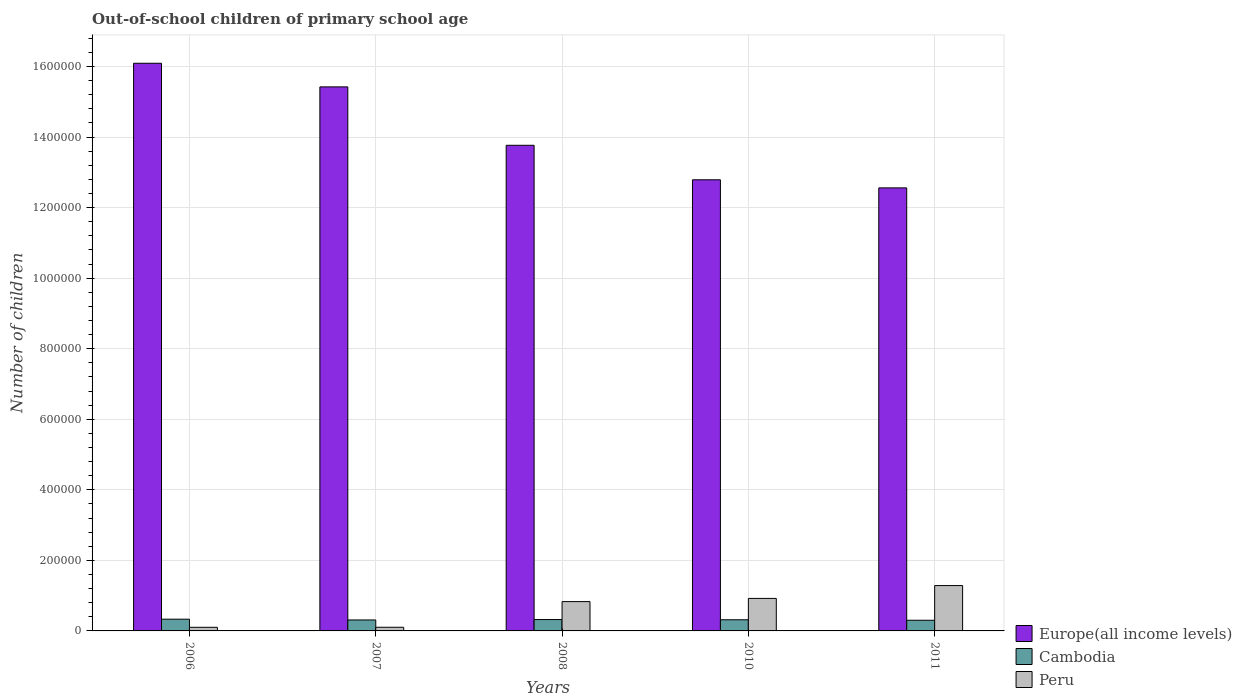Are the number of bars per tick equal to the number of legend labels?
Give a very brief answer. Yes. Are the number of bars on each tick of the X-axis equal?
Provide a short and direct response. Yes. How many bars are there on the 4th tick from the right?
Your answer should be very brief. 3. What is the label of the 3rd group of bars from the left?
Your answer should be very brief. 2008. In how many cases, is the number of bars for a given year not equal to the number of legend labels?
Provide a succinct answer. 0. What is the number of out-of-school children in Europe(all income levels) in 2010?
Make the answer very short. 1.28e+06. Across all years, what is the maximum number of out-of-school children in Cambodia?
Your response must be concise. 3.33e+04. Across all years, what is the minimum number of out-of-school children in Europe(all income levels)?
Provide a short and direct response. 1.26e+06. In which year was the number of out-of-school children in Europe(all income levels) maximum?
Make the answer very short. 2006. What is the total number of out-of-school children in Europe(all income levels) in the graph?
Ensure brevity in your answer.  7.06e+06. What is the difference between the number of out-of-school children in Cambodia in 2006 and that in 2007?
Give a very brief answer. 2244. What is the difference between the number of out-of-school children in Cambodia in 2007 and the number of out-of-school children in Europe(all income levels) in 2010?
Keep it short and to the point. -1.25e+06. What is the average number of out-of-school children in Peru per year?
Keep it short and to the point. 6.49e+04. In the year 2007, what is the difference between the number of out-of-school children in Cambodia and number of out-of-school children in Europe(all income levels)?
Offer a terse response. -1.51e+06. In how many years, is the number of out-of-school children in Europe(all income levels) greater than 1040000?
Ensure brevity in your answer.  5. What is the ratio of the number of out-of-school children in Cambodia in 2006 to that in 2011?
Your answer should be very brief. 1.1. Is the difference between the number of out-of-school children in Cambodia in 2006 and 2010 greater than the difference between the number of out-of-school children in Europe(all income levels) in 2006 and 2010?
Your response must be concise. No. What is the difference between the highest and the second highest number of out-of-school children in Cambodia?
Provide a short and direct response. 1097. What is the difference between the highest and the lowest number of out-of-school children in Europe(all income levels)?
Offer a terse response. 3.53e+05. What does the 2nd bar from the left in 2006 represents?
Your response must be concise. Cambodia. How many bars are there?
Your answer should be compact. 15. Are all the bars in the graph horizontal?
Give a very brief answer. No. How many years are there in the graph?
Ensure brevity in your answer.  5. What is the difference between two consecutive major ticks on the Y-axis?
Offer a very short reply. 2.00e+05. Does the graph contain any zero values?
Your answer should be very brief. No. Does the graph contain grids?
Offer a terse response. Yes. How many legend labels are there?
Your response must be concise. 3. What is the title of the graph?
Your response must be concise. Out-of-school children of primary school age. Does "Puerto Rico" appear as one of the legend labels in the graph?
Your answer should be compact. No. What is the label or title of the Y-axis?
Offer a terse response. Number of children. What is the Number of children of Europe(all income levels) in 2006?
Ensure brevity in your answer.  1.61e+06. What is the Number of children of Cambodia in 2006?
Your response must be concise. 3.33e+04. What is the Number of children in Peru in 2006?
Offer a terse response. 1.03e+04. What is the Number of children of Europe(all income levels) in 2007?
Your answer should be compact. 1.54e+06. What is the Number of children in Cambodia in 2007?
Keep it short and to the point. 3.11e+04. What is the Number of children of Peru in 2007?
Ensure brevity in your answer.  1.04e+04. What is the Number of children of Europe(all income levels) in 2008?
Offer a terse response. 1.38e+06. What is the Number of children of Cambodia in 2008?
Make the answer very short. 3.22e+04. What is the Number of children of Peru in 2008?
Give a very brief answer. 8.31e+04. What is the Number of children in Europe(all income levels) in 2010?
Your answer should be compact. 1.28e+06. What is the Number of children of Cambodia in 2010?
Make the answer very short. 3.16e+04. What is the Number of children of Peru in 2010?
Provide a short and direct response. 9.21e+04. What is the Number of children of Europe(all income levels) in 2011?
Provide a short and direct response. 1.26e+06. What is the Number of children of Cambodia in 2011?
Make the answer very short. 3.02e+04. What is the Number of children in Peru in 2011?
Your answer should be very brief. 1.29e+05. Across all years, what is the maximum Number of children of Europe(all income levels)?
Offer a terse response. 1.61e+06. Across all years, what is the maximum Number of children in Cambodia?
Provide a short and direct response. 3.33e+04. Across all years, what is the maximum Number of children in Peru?
Offer a very short reply. 1.29e+05. Across all years, what is the minimum Number of children of Europe(all income levels)?
Keep it short and to the point. 1.26e+06. Across all years, what is the minimum Number of children of Cambodia?
Keep it short and to the point. 3.02e+04. Across all years, what is the minimum Number of children in Peru?
Provide a succinct answer. 1.03e+04. What is the total Number of children of Europe(all income levels) in the graph?
Offer a very short reply. 7.06e+06. What is the total Number of children of Cambodia in the graph?
Give a very brief answer. 1.58e+05. What is the total Number of children of Peru in the graph?
Your response must be concise. 3.24e+05. What is the difference between the Number of children of Europe(all income levels) in 2006 and that in 2007?
Your answer should be very brief. 6.69e+04. What is the difference between the Number of children of Cambodia in 2006 and that in 2007?
Your response must be concise. 2244. What is the difference between the Number of children of Peru in 2006 and that in 2007?
Your answer should be compact. -136. What is the difference between the Number of children in Europe(all income levels) in 2006 and that in 2008?
Your response must be concise. 2.33e+05. What is the difference between the Number of children in Cambodia in 2006 and that in 2008?
Provide a short and direct response. 1097. What is the difference between the Number of children of Peru in 2006 and that in 2008?
Provide a succinct answer. -7.29e+04. What is the difference between the Number of children in Europe(all income levels) in 2006 and that in 2010?
Keep it short and to the point. 3.30e+05. What is the difference between the Number of children of Cambodia in 2006 and that in 2010?
Offer a terse response. 1695. What is the difference between the Number of children in Peru in 2006 and that in 2010?
Your response must be concise. -8.19e+04. What is the difference between the Number of children in Europe(all income levels) in 2006 and that in 2011?
Your response must be concise. 3.53e+05. What is the difference between the Number of children of Cambodia in 2006 and that in 2011?
Your answer should be compact. 3092. What is the difference between the Number of children of Peru in 2006 and that in 2011?
Keep it short and to the point. -1.18e+05. What is the difference between the Number of children in Europe(all income levels) in 2007 and that in 2008?
Keep it short and to the point. 1.66e+05. What is the difference between the Number of children of Cambodia in 2007 and that in 2008?
Your answer should be compact. -1147. What is the difference between the Number of children of Peru in 2007 and that in 2008?
Your answer should be compact. -7.27e+04. What is the difference between the Number of children in Europe(all income levels) in 2007 and that in 2010?
Your answer should be compact. 2.63e+05. What is the difference between the Number of children in Cambodia in 2007 and that in 2010?
Your answer should be very brief. -549. What is the difference between the Number of children in Peru in 2007 and that in 2010?
Keep it short and to the point. -8.18e+04. What is the difference between the Number of children of Europe(all income levels) in 2007 and that in 2011?
Ensure brevity in your answer.  2.86e+05. What is the difference between the Number of children of Cambodia in 2007 and that in 2011?
Provide a short and direct response. 848. What is the difference between the Number of children in Peru in 2007 and that in 2011?
Give a very brief answer. -1.18e+05. What is the difference between the Number of children in Europe(all income levels) in 2008 and that in 2010?
Make the answer very short. 9.78e+04. What is the difference between the Number of children of Cambodia in 2008 and that in 2010?
Provide a succinct answer. 598. What is the difference between the Number of children of Peru in 2008 and that in 2010?
Provide a succinct answer. -9027. What is the difference between the Number of children of Europe(all income levels) in 2008 and that in 2011?
Offer a terse response. 1.21e+05. What is the difference between the Number of children of Cambodia in 2008 and that in 2011?
Give a very brief answer. 1995. What is the difference between the Number of children of Peru in 2008 and that in 2011?
Offer a terse response. -4.54e+04. What is the difference between the Number of children of Europe(all income levels) in 2010 and that in 2011?
Give a very brief answer. 2.30e+04. What is the difference between the Number of children of Cambodia in 2010 and that in 2011?
Provide a succinct answer. 1397. What is the difference between the Number of children of Peru in 2010 and that in 2011?
Provide a succinct answer. -3.64e+04. What is the difference between the Number of children of Europe(all income levels) in 2006 and the Number of children of Cambodia in 2007?
Give a very brief answer. 1.58e+06. What is the difference between the Number of children in Europe(all income levels) in 2006 and the Number of children in Peru in 2007?
Your response must be concise. 1.60e+06. What is the difference between the Number of children of Cambodia in 2006 and the Number of children of Peru in 2007?
Make the answer very short. 2.29e+04. What is the difference between the Number of children in Europe(all income levels) in 2006 and the Number of children in Cambodia in 2008?
Provide a short and direct response. 1.58e+06. What is the difference between the Number of children of Europe(all income levels) in 2006 and the Number of children of Peru in 2008?
Make the answer very short. 1.53e+06. What is the difference between the Number of children of Cambodia in 2006 and the Number of children of Peru in 2008?
Ensure brevity in your answer.  -4.98e+04. What is the difference between the Number of children of Europe(all income levels) in 2006 and the Number of children of Cambodia in 2010?
Ensure brevity in your answer.  1.58e+06. What is the difference between the Number of children in Europe(all income levels) in 2006 and the Number of children in Peru in 2010?
Your answer should be very brief. 1.52e+06. What is the difference between the Number of children in Cambodia in 2006 and the Number of children in Peru in 2010?
Make the answer very short. -5.88e+04. What is the difference between the Number of children of Europe(all income levels) in 2006 and the Number of children of Cambodia in 2011?
Make the answer very short. 1.58e+06. What is the difference between the Number of children of Europe(all income levels) in 2006 and the Number of children of Peru in 2011?
Offer a terse response. 1.48e+06. What is the difference between the Number of children of Cambodia in 2006 and the Number of children of Peru in 2011?
Your response must be concise. -9.52e+04. What is the difference between the Number of children in Europe(all income levels) in 2007 and the Number of children in Cambodia in 2008?
Offer a terse response. 1.51e+06. What is the difference between the Number of children in Europe(all income levels) in 2007 and the Number of children in Peru in 2008?
Your answer should be very brief. 1.46e+06. What is the difference between the Number of children of Cambodia in 2007 and the Number of children of Peru in 2008?
Your answer should be very brief. -5.21e+04. What is the difference between the Number of children in Europe(all income levels) in 2007 and the Number of children in Cambodia in 2010?
Keep it short and to the point. 1.51e+06. What is the difference between the Number of children in Europe(all income levels) in 2007 and the Number of children in Peru in 2010?
Provide a short and direct response. 1.45e+06. What is the difference between the Number of children of Cambodia in 2007 and the Number of children of Peru in 2010?
Provide a succinct answer. -6.11e+04. What is the difference between the Number of children in Europe(all income levels) in 2007 and the Number of children in Cambodia in 2011?
Offer a terse response. 1.51e+06. What is the difference between the Number of children in Europe(all income levels) in 2007 and the Number of children in Peru in 2011?
Keep it short and to the point. 1.41e+06. What is the difference between the Number of children in Cambodia in 2007 and the Number of children in Peru in 2011?
Offer a terse response. -9.75e+04. What is the difference between the Number of children of Europe(all income levels) in 2008 and the Number of children of Cambodia in 2010?
Provide a succinct answer. 1.34e+06. What is the difference between the Number of children of Europe(all income levels) in 2008 and the Number of children of Peru in 2010?
Your answer should be compact. 1.28e+06. What is the difference between the Number of children in Cambodia in 2008 and the Number of children in Peru in 2010?
Provide a succinct answer. -5.99e+04. What is the difference between the Number of children of Europe(all income levels) in 2008 and the Number of children of Cambodia in 2011?
Your answer should be compact. 1.35e+06. What is the difference between the Number of children in Europe(all income levels) in 2008 and the Number of children in Peru in 2011?
Give a very brief answer. 1.25e+06. What is the difference between the Number of children of Cambodia in 2008 and the Number of children of Peru in 2011?
Ensure brevity in your answer.  -9.63e+04. What is the difference between the Number of children of Europe(all income levels) in 2010 and the Number of children of Cambodia in 2011?
Keep it short and to the point. 1.25e+06. What is the difference between the Number of children in Europe(all income levels) in 2010 and the Number of children in Peru in 2011?
Ensure brevity in your answer.  1.15e+06. What is the difference between the Number of children of Cambodia in 2010 and the Number of children of Peru in 2011?
Your response must be concise. -9.69e+04. What is the average Number of children of Europe(all income levels) per year?
Offer a very short reply. 1.41e+06. What is the average Number of children of Cambodia per year?
Ensure brevity in your answer.  3.17e+04. What is the average Number of children of Peru per year?
Give a very brief answer. 6.49e+04. In the year 2006, what is the difference between the Number of children in Europe(all income levels) and Number of children in Cambodia?
Give a very brief answer. 1.58e+06. In the year 2006, what is the difference between the Number of children of Europe(all income levels) and Number of children of Peru?
Keep it short and to the point. 1.60e+06. In the year 2006, what is the difference between the Number of children of Cambodia and Number of children of Peru?
Make the answer very short. 2.30e+04. In the year 2007, what is the difference between the Number of children in Europe(all income levels) and Number of children in Cambodia?
Offer a very short reply. 1.51e+06. In the year 2007, what is the difference between the Number of children in Europe(all income levels) and Number of children in Peru?
Ensure brevity in your answer.  1.53e+06. In the year 2007, what is the difference between the Number of children in Cambodia and Number of children in Peru?
Offer a very short reply. 2.07e+04. In the year 2008, what is the difference between the Number of children of Europe(all income levels) and Number of children of Cambodia?
Make the answer very short. 1.34e+06. In the year 2008, what is the difference between the Number of children in Europe(all income levels) and Number of children in Peru?
Provide a short and direct response. 1.29e+06. In the year 2008, what is the difference between the Number of children of Cambodia and Number of children of Peru?
Your answer should be compact. -5.09e+04. In the year 2010, what is the difference between the Number of children in Europe(all income levels) and Number of children in Cambodia?
Offer a terse response. 1.25e+06. In the year 2010, what is the difference between the Number of children of Europe(all income levels) and Number of children of Peru?
Provide a short and direct response. 1.19e+06. In the year 2010, what is the difference between the Number of children of Cambodia and Number of children of Peru?
Offer a terse response. -6.05e+04. In the year 2011, what is the difference between the Number of children in Europe(all income levels) and Number of children in Cambodia?
Provide a short and direct response. 1.23e+06. In the year 2011, what is the difference between the Number of children in Europe(all income levels) and Number of children in Peru?
Ensure brevity in your answer.  1.13e+06. In the year 2011, what is the difference between the Number of children of Cambodia and Number of children of Peru?
Provide a succinct answer. -9.83e+04. What is the ratio of the Number of children in Europe(all income levels) in 2006 to that in 2007?
Keep it short and to the point. 1.04. What is the ratio of the Number of children in Cambodia in 2006 to that in 2007?
Your answer should be very brief. 1.07. What is the ratio of the Number of children in Peru in 2006 to that in 2007?
Ensure brevity in your answer.  0.99. What is the ratio of the Number of children of Europe(all income levels) in 2006 to that in 2008?
Offer a very short reply. 1.17. What is the ratio of the Number of children in Cambodia in 2006 to that in 2008?
Offer a terse response. 1.03. What is the ratio of the Number of children in Peru in 2006 to that in 2008?
Give a very brief answer. 0.12. What is the ratio of the Number of children in Europe(all income levels) in 2006 to that in 2010?
Make the answer very short. 1.26. What is the ratio of the Number of children in Cambodia in 2006 to that in 2010?
Keep it short and to the point. 1.05. What is the ratio of the Number of children in Peru in 2006 to that in 2010?
Make the answer very short. 0.11. What is the ratio of the Number of children of Europe(all income levels) in 2006 to that in 2011?
Offer a terse response. 1.28. What is the ratio of the Number of children of Cambodia in 2006 to that in 2011?
Provide a short and direct response. 1.1. What is the ratio of the Number of children of Peru in 2006 to that in 2011?
Ensure brevity in your answer.  0.08. What is the ratio of the Number of children in Europe(all income levels) in 2007 to that in 2008?
Keep it short and to the point. 1.12. What is the ratio of the Number of children in Cambodia in 2007 to that in 2008?
Provide a short and direct response. 0.96. What is the ratio of the Number of children in Europe(all income levels) in 2007 to that in 2010?
Make the answer very short. 1.21. What is the ratio of the Number of children of Cambodia in 2007 to that in 2010?
Your response must be concise. 0.98. What is the ratio of the Number of children of Peru in 2007 to that in 2010?
Ensure brevity in your answer.  0.11. What is the ratio of the Number of children of Europe(all income levels) in 2007 to that in 2011?
Make the answer very short. 1.23. What is the ratio of the Number of children in Cambodia in 2007 to that in 2011?
Your answer should be compact. 1.03. What is the ratio of the Number of children of Peru in 2007 to that in 2011?
Your response must be concise. 0.08. What is the ratio of the Number of children in Europe(all income levels) in 2008 to that in 2010?
Ensure brevity in your answer.  1.08. What is the ratio of the Number of children of Cambodia in 2008 to that in 2010?
Ensure brevity in your answer.  1.02. What is the ratio of the Number of children in Peru in 2008 to that in 2010?
Your answer should be very brief. 0.9. What is the ratio of the Number of children of Europe(all income levels) in 2008 to that in 2011?
Keep it short and to the point. 1.1. What is the ratio of the Number of children in Cambodia in 2008 to that in 2011?
Your response must be concise. 1.07. What is the ratio of the Number of children of Peru in 2008 to that in 2011?
Give a very brief answer. 0.65. What is the ratio of the Number of children in Europe(all income levels) in 2010 to that in 2011?
Offer a very short reply. 1.02. What is the ratio of the Number of children of Cambodia in 2010 to that in 2011?
Keep it short and to the point. 1.05. What is the ratio of the Number of children of Peru in 2010 to that in 2011?
Keep it short and to the point. 0.72. What is the difference between the highest and the second highest Number of children in Europe(all income levels)?
Offer a very short reply. 6.69e+04. What is the difference between the highest and the second highest Number of children in Cambodia?
Your answer should be compact. 1097. What is the difference between the highest and the second highest Number of children in Peru?
Offer a terse response. 3.64e+04. What is the difference between the highest and the lowest Number of children in Europe(all income levels)?
Your response must be concise. 3.53e+05. What is the difference between the highest and the lowest Number of children of Cambodia?
Give a very brief answer. 3092. What is the difference between the highest and the lowest Number of children in Peru?
Provide a short and direct response. 1.18e+05. 